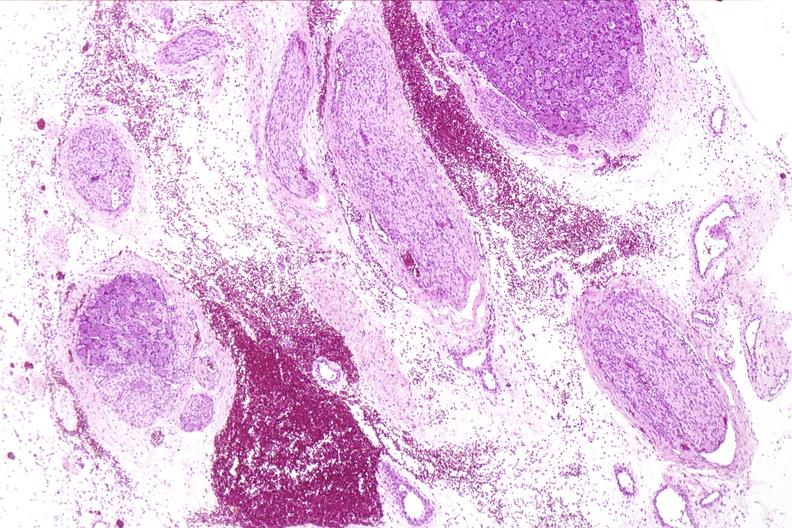where is this?
Answer the question using a single word or phrase. Nervous 